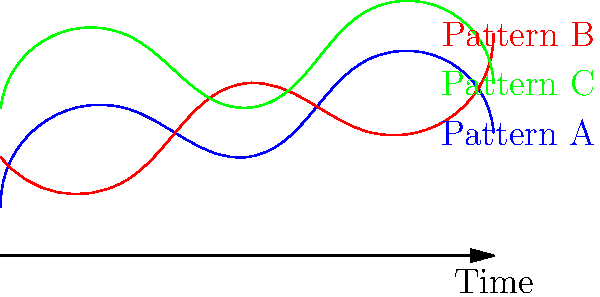Based on the time-lapse diagram showing three different crowd movement patterns (A, B, and C) during a concert, which pattern would likely create the most consistent and energetic atmosphere for the band's performance? To determine which crowd movement pattern would create the most consistent and energetic atmosphere, we need to analyze each pattern:

1. Pattern A (blue):
   - Starts low, rises quickly, then fluctuates with moderate peaks and valleys
   - Indicates inconsistent energy levels with occasional high points

2. Pattern B (red):
   - Begins at a moderate level, dips slightly, then shows a gradual increase with some fluctuations
   - Suggests a building energy that grows over time, but with some inconsistency

3. Pattern C (green):
   - Starts at a higher energy level, maintains consistently high peaks throughout
   - Shows the most regular and sustained high-energy movement

As a lead singer relying on the crowd's rhythm:
- Consistent high energy is crucial for maintaining the band's tight performance
- Regular peaks in crowd movement can help energize the band throughout the show
- A pattern that starts strong and maintains that energy is ideal for setting and keeping the right atmosphere

Pattern C demonstrates the most consistent high-energy movement, with regular peaks and relatively small valleys. This would provide the most reliable rhythm and energy for the band to feed off of throughout the performance.
Answer: Pattern C 